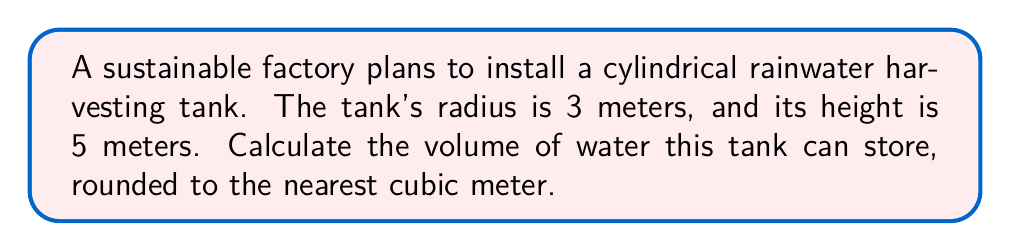Give your solution to this math problem. To solve this problem, we'll follow these steps:

1) The volume of a cylinder is given by the formula:
   $$V = \pi r^2 h$$
   where $V$ is volume, $r$ is radius, and $h$ is height.

2) We're given:
   $r = 3$ meters
   $h = 5$ meters

3) Let's substitute these values into our formula:
   $$V = \pi (3\text{ m})^2 (5\text{ m})$$

4) Simplify the expression inside the parentheses:
   $$V = \pi (9\text{ m}^2) (5\text{ m})$$

5) Multiply:
   $$V = 45\pi\text{ m}^3$$

6) Calculate (using 3.14159 for $\pi$):
   $$V \approx 141.37\text{ m}^3$$

7) Rounding to the nearest cubic meter:
   $$V \approx 141\text{ m}^3$$

This cylindrical tank can store approximately 141 cubic meters of rainwater.
Answer: 141 m³ 